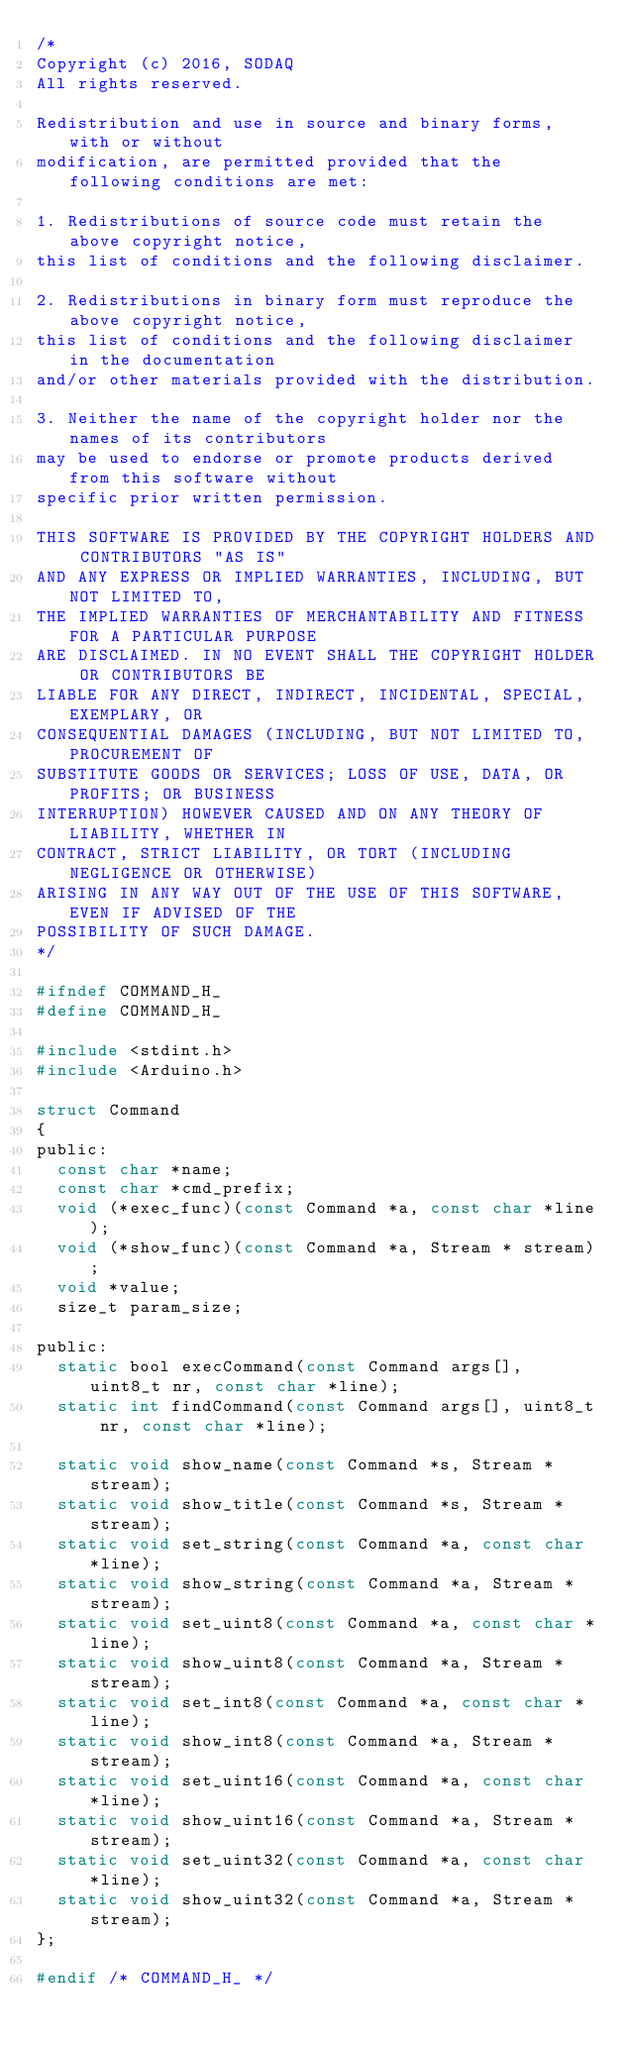Convert code to text. <code><loc_0><loc_0><loc_500><loc_500><_C_>/*
Copyright (c) 2016, SODAQ
All rights reserved.

Redistribution and use in source and binary forms, with or without
modification, are permitted provided that the following conditions are met:

1. Redistributions of source code must retain the above copyright notice,
this list of conditions and the following disclaimer.

2. Redistributions in binary form must reproduce the above copyright notice,
this list of conditions and the following disclaimer in the documentation
and/or other materials provided with the distribution.

3. Neither the name of the copyright holder nor the names of its contributors
may be used to endorse or promote products derived from this software without
specific prior written permission.

THIS SOFTWARE IS PROVIDED BY THE COPYRIGHT HOLDERS AND CONTRIBUTORS "AS IS"
AND ANY EXPRESS OR IMPLIED WARRANTIES, INCLUDING, BUT NOT LIMITED TO,
THE IMPLIED WARRANTIES OF MERCHANTABILITY AND FITNESS FOR A PARTICULAR PURPOSE
ARE DISCLAIMED. IN NO EVENT SHALL THE COPYRIGHT HOLDER OR CONTRIBUTORS BE
LIABLE FOR ANY DIRECT, INDIRECT, INCIDENTAL, SPECIAL, EXEMPLARY, OR
CONSEQUENTIAL DAMAGES (INCLUDING, BUT NOT LIMITED TO, PROCUREMENT OF
SUBSTITUTE GOODS OR SERVICES; LOSS OF USE, DATA, OR PROFITS; OR BUSINESS
INTERRUPTION) HOWEVER CAUSED AND ON ANY THEORY OF LIABILITY, WHETHER IN
CONTRACT, STRICT LIABILITY, OR TORT (INCLUDING NEGLIGENCE OR OTHERWISE)
ARISING IN ANY WAY OUT OF THE USE OF THIS SOFTWARE, EVEN IF ADVISED OF THE
POSSIBILITY OF SUCH DAMAGE.
*/

#ifndef COMMAND_H_
#define COMMAND_H_

#include <stdint.h>
#include <Arduino.h>

struct Command
{
public:
  const char *name;
  const char *cmd_prefix;
  void (*exec_func)(const Command *a, const char *line);
  void (*show_func)(const Command *a, Stream * stream);
  void *value;
  size_t param_size;

public:
  static bool execCommand(const Command args[], uint8_t nr, const char *line);
  static int findCommand(const Command args[], uint8_t nr, const char *line);

  static void show_name(const Command *s, Stream * stream);
  static void show_title(const Command *s, Stream * stream);
  static void set_string(const Command *a, const char *line);
  static void show_string(const Command *a, Stream * stream);
  static void set_uint8(const Command *a, const char *line);
  static void show_uint8(const Command *a, Stream * stream);
  static void set_int8(const Command *a, const char *line);
  static void show_int8(const Command *a, Stream * stream);
  static void set_uint16(const Command *a, const char *line);
  static void show_uint16(const Command *a, Stream * stream);
  static void set_uint32(const Command *a, const char *line);
  static void show_uint32(const Command *a, Stream * stream);
};

#endif /* COMMAND_H_ */
</code> 